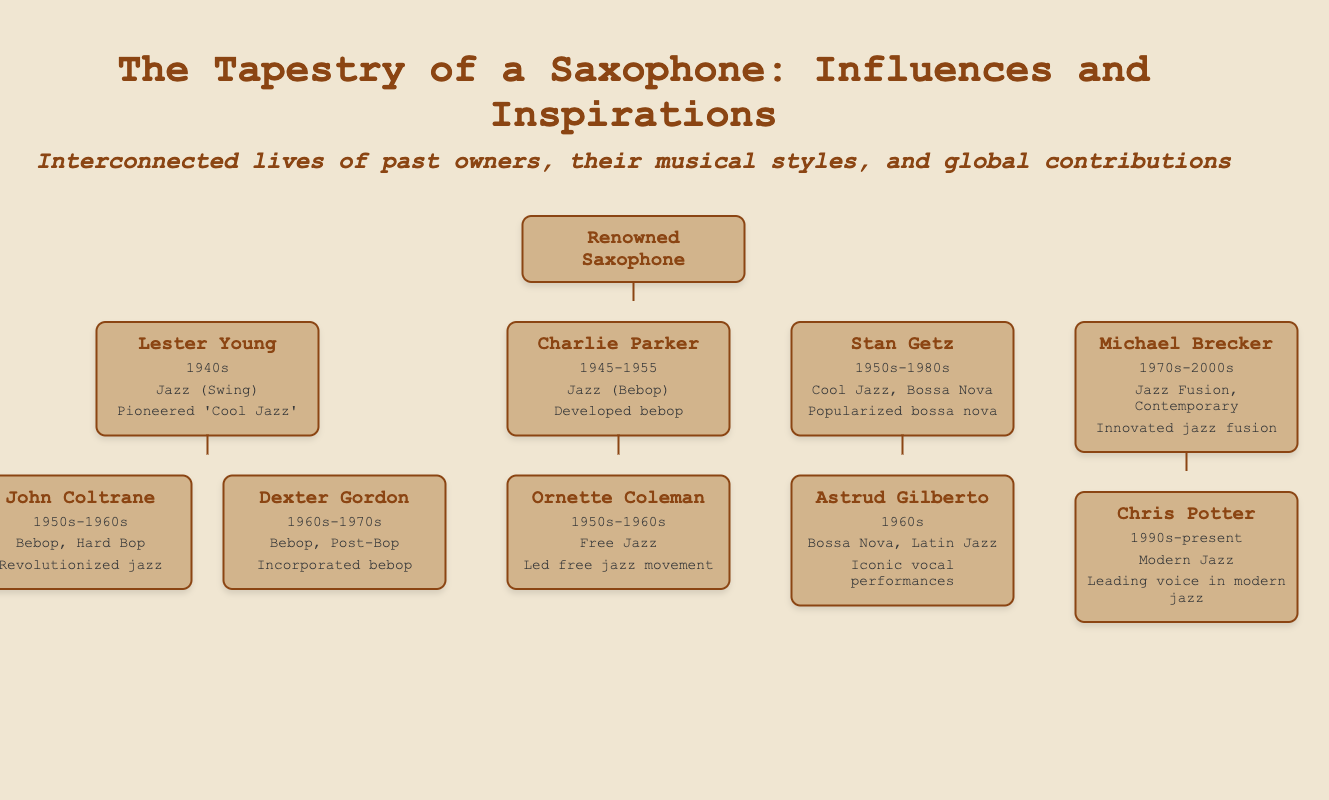what is the name of the renowned saxophone? The document introduces the saxophone simply as "Renowned Saxophone."
Answer: Renowned Saxophone who was the first owner of the saxophone? The first owner listed is Lester Young, who played in the 1940s.
Answer: Lester Young which musical style did John Coltrane primarily play? John Coltrane is noted for revolutionizing jazz with his Bebop and Hard Bop styles.
Answer: Bebop, Hard Bop what decade did Charlie Parker own the saxophone? Charlie Parker is documented as owning the saxophone from 1945 to 1955.
Answer: 1945-1955 which artist popularized bossa nova? The document states that Stan Getz popularized bossa nova.
Answer: Stan Getz how many owners are connected directly to Lester Young? There are two owners connected directly to Lester Young: John Coltrane and Dexter Gordon.
Answer: 2 what is the musical genre associated with Ornette Coleman? Ornette Coleman is associated with the Free Jazz genre.
Answer: Free Jazz in which period did Michael Brecker innovate jazz fusion? Michael Brecker's innovation in jazz fusion spanned from the 1970s to the 2000s.
Answer: 1970s-2000s who is the leading voice in modern jazz according to the document? Chris Potter is identified as the leading voice in modern jazz.
Answer: Chris Potter 